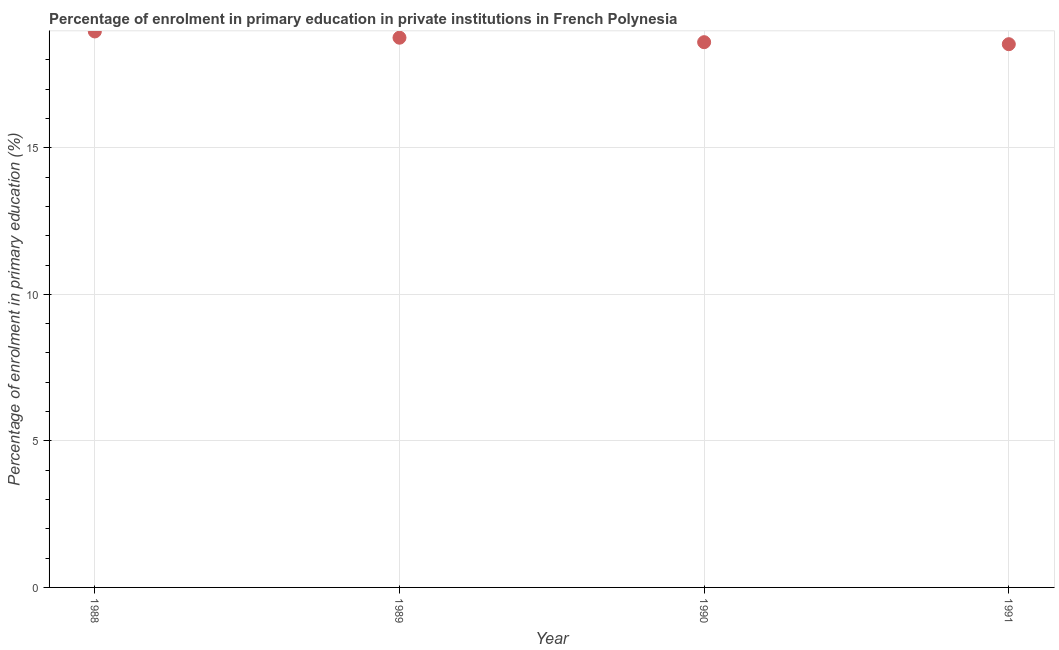What is the enrolment percentage in primary education in 1990?
Keep it short and to the point. 18.6. Across all years, what is the maximum enrolment percentage in primary education?
Your answer should be compact. 18.97. Across all years, what is the minimum enrolment percentage in primary education?
Offer a terse response. 18.54. In which year was the enrolment percentage in primary education maximum?
Your answer should be compact. 1988. What is the sum of the enrolment percentage in primary education?
Keep it short and to the point. 74.87. What is the difference between the enrolment percentage in primary education in 1988 and 1989?
Your response must be concise. 0.21. What is the average enrolment percentage in primary education per year?
Ensure brevity in your answer.  18.72. What is the median enrolment percentage in primary education?
Your response must be concise. 18.68. In how many years, is the enrolment percentage in primary education greater than 9 %?
Give a very brief answer. 4. What is the ratio of the enrolment percentage in primary education in 1989 to that in 1991?
Provide a succinct answer. 1.01. Is the difference between the enrolment percentage in primary education in 1988 and 1991 greater than the difference between any two years?
Offer a very short reply. Yes. What is the difference between the highest and the second highest enrolment percentage in primary education?
Your answer should be very brief. 0.21. What is the difference between the highest and the lowest enrolment percentage in primary education?
Give a very brief answer. 0.43. In how many years, is the enrolment percentage in primary education greater than the average enrolment percentage in primary education taken over all years?
Give a very brief answer. 2. Does the enrolment percentage in primary education monotonically increase over the years?
Provide a succinct answer. No. What is the difference between two consecutive major ticks on the Y-axis?
Your response must be concise. 5. Are the values on the major ticks of Y-axis written in scientific E-notation?
Offer a terse response. No. Does the graph contain any zero values?
Your answer should be very brief. No. What is the title of the graph?
Your answer should be compact. Percentage of enrolment in primary education in private institutions in French Polynesia. What is the label or title of the Y-axis?
Ensure brevity in your answer.  Percentage of enrolment in primary education (%). What is the Percentage of enrolment in primary education (%) in 1988?
Provide a short and direct response. 18.97. What is the Percentage of enrolment in primary education (%) in 1989?
Make the answer very short. 18.76. What is the Percentage of enrolment in primary education (%) in 1990?
Your answer should be very brief. 18.6. What is the Percentage of enrolment in primary education (%) in 1991?
Give a very brief answer. 18.54. What is the difference between the Percentage of enrolment in primary education (%) in 1988 and 1989?
Make the answer very short. 0.21. What is the difference between the Percentage of enrolment in primary education (%) in 1988 and 1990?
Provide a succinct answer. 0.37. What is the difference between the Percentage of enrolment in primary education (%) in 1988 and 1991?
Provide a short and direct response. 0.43. What is the difference between the Percentage of enrolment in primary education (%) in 1989 and 1990?
Keep it short and to the point. 0.15. What is the difference between the Percentage of enrolment in primary education (%) in 1989 and 1991?
Give a very brief answer. 0.22. What is the difference between the Percentage of enrolment in primary education (%) in 1990 and 1991?
Provide a short and direct response. 0.07. What is the ratio of the Percentage of enrolment in primary education (%) in 1988 to that in 1989?
Offer a very short reply. 1.01. What is the ratio of the Percentage of enrolment in primary education (%) in 1988 to that in 1991?
Your answer should be very brief. 1.02. What is the ratio of the Percentage of enrolment in primary education (%) in 1989 to that in 1990?
Ensure brevity in your answer.  1.01. What is the ratio of the Percentage of enrolment in primary education (%) in 1990 to that in 1991?
Provide a short and direct response. 1. 